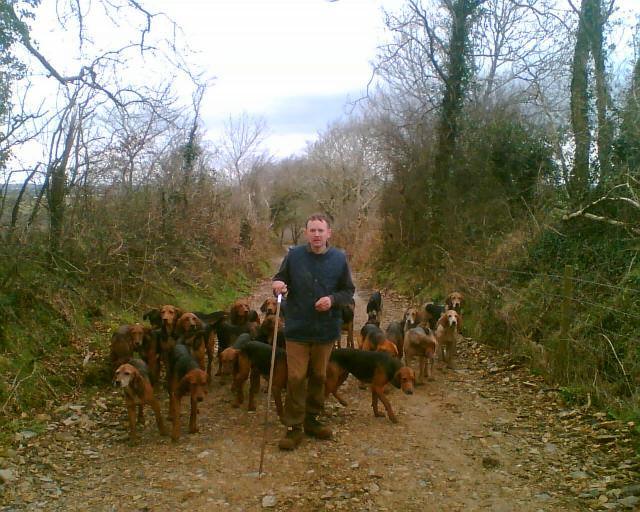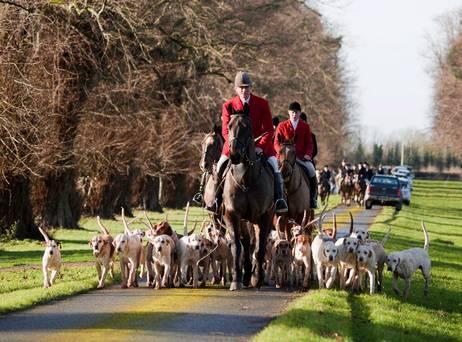The first image is the image on the left, the second image is the image on the right. Analyze the images presented: Is the assertion "There are dogs and horses." valid? Answer yes or no. Yes. The first image is the image on the left, the second image is the image on the right. Assess this claim about the two images: "An image contains a large herd of dogs following a man on a horse that is wearing a red jacket.". Correct or not? Answer yes or no. Yes. 